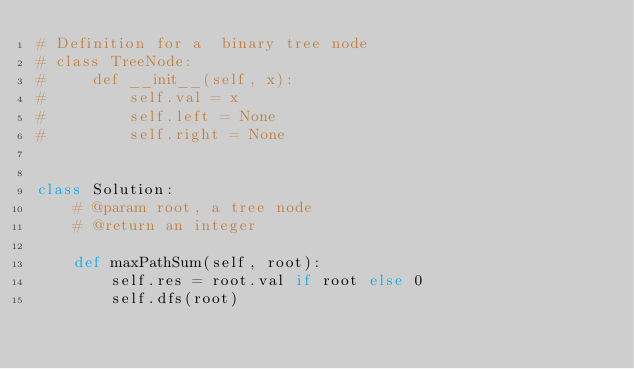Convert code to text. <code><loc_0><loc_0><loc_500><loc_500><_Python_># Definition for a  binary tree node
# class TreeNode:
#     def __init__(self, x):
#         self.val = x
#         self.left = None
#         self.right = None


class Solution:
    # @param root, a tree node
    # @return an integer

    def maxPathSum(self, root):
        self.res = root.val if root else 0
        self.dfs(root)</code> 